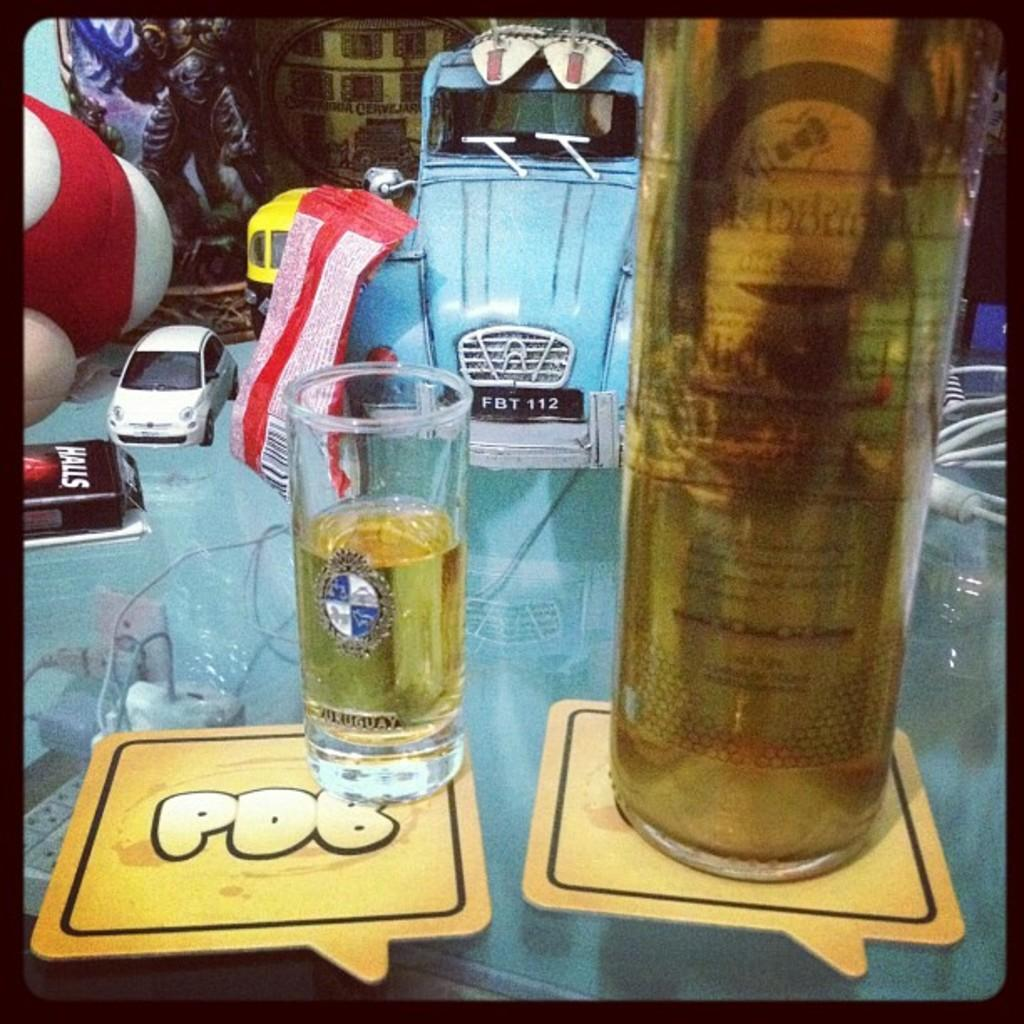<image>
Give a short and clear explanation of the subsequent image. A glass and a bottle with light golden liquid placed on coasters that says PDB. 